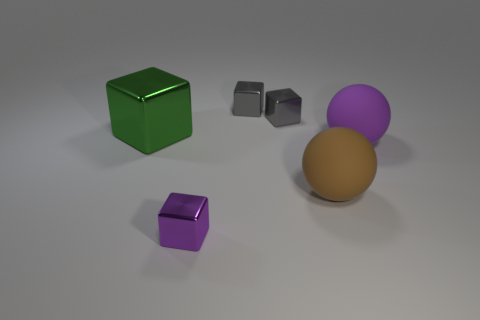There is a large thing on the left side of the purple thing that is in front of the brown rubber thing; is there a green cube that is left of it? no 